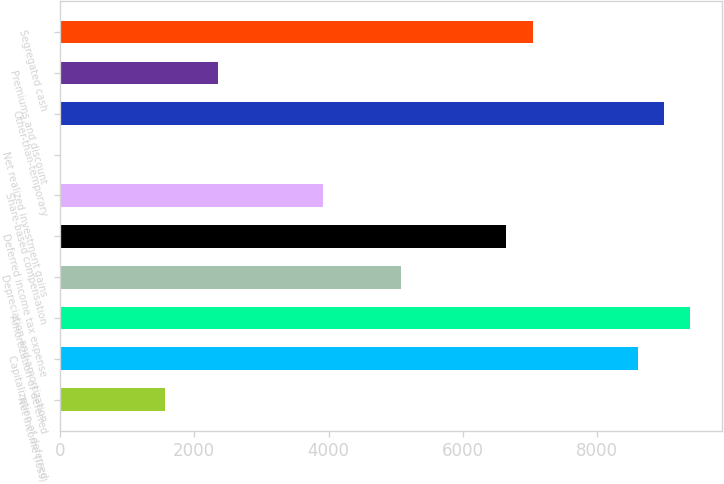Convert chart to OTSL. <chart><loc_0><loc_0><loc_500><loc_500><bar_chart><fcel>Net income (loss)<fcel>Capitalization of deferred<fcel>Amortization of deferred<fcel>Depreciation and amortization<fcel>Deferred income tax expense<fcel>Share-based compensation<fcel>Net realized investment gains<fcel>Other-than-temporary<fcel>Premiums and discount<fcel>Segregated cash<nl><fcel>1567.4<fcel>8598.2<fcel>9379.4<fcel>5082.8<fcel>6645.2<fcel>3911<fcel>5<fcel>8988.8<fcel>2348.6<fcel>7035.8<nl></chart> 